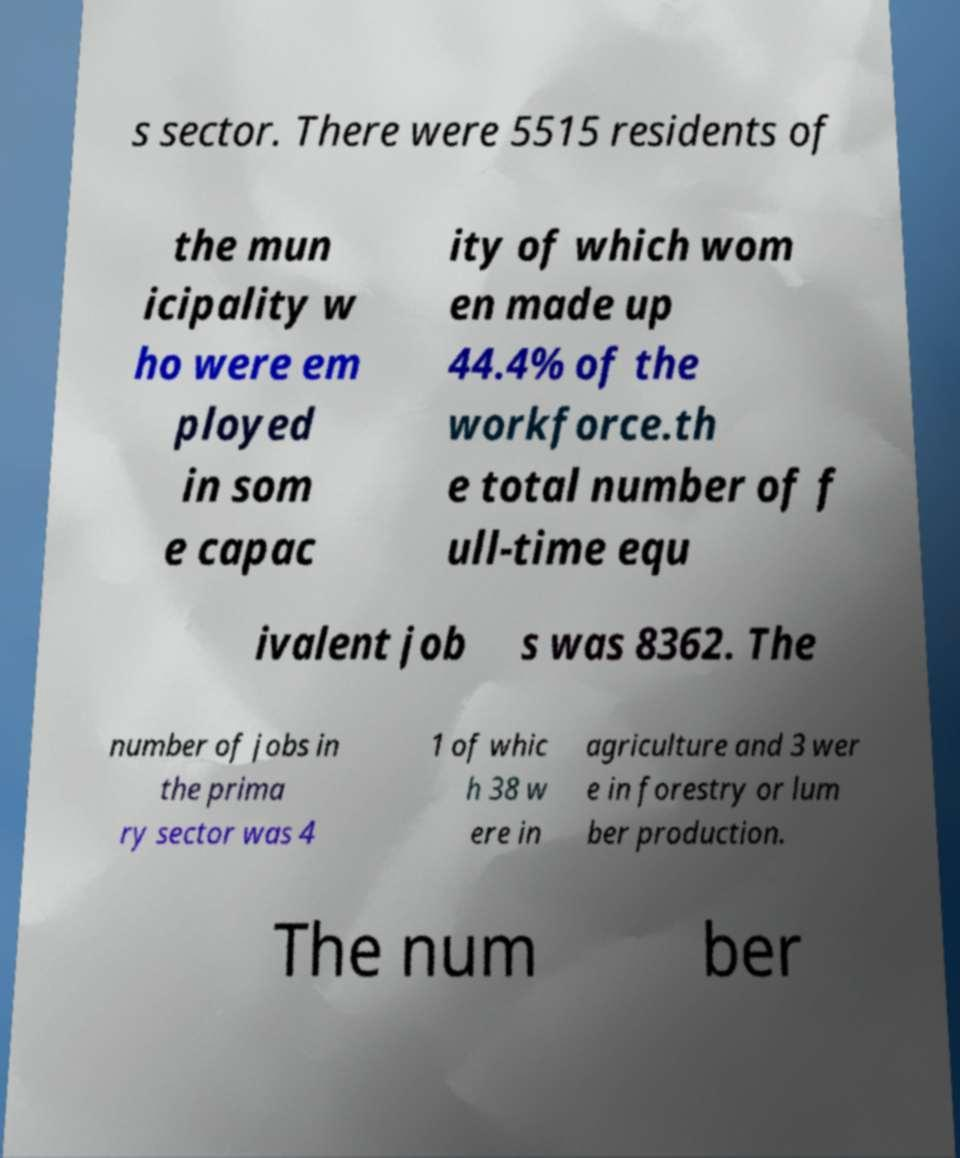Could you extract and type out the text from this image? s sector. There were 5515 residents of the mun icipality w ho were em ployed in som e capac ity of which wom en made up 44.4% of the workforce.th e total number of f ull-time equ ivalent job s was 8362. The number of jobs in the prima ry sector was 4 1 of whic h 38 w ere in agriculture and 3 wer e in forestry or lum ber production. The num ber 